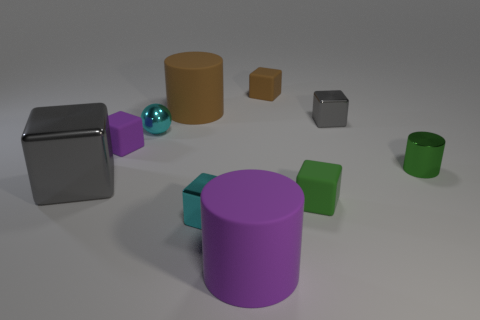Do the small metal cylinder and the large cylinder that is behind the tiny cyan metal block have the same color?
Give a very brief answer. No. Are there more purple matte objects than gray matte things?
Provide a short and direct response. Yes. Are there any other things of the same color as the small cylinder?
Provide a short and direct response. Yes. How many other things are there of the same size as the green metallic object?
Keep it short and to the point. 6. The cyan object that is behind the green thing that is in front of the green metallic cylinder that is in front of the large brown thing is made of what material?
Provide a succinct answer. Metal. Does the small purple thing have the same material as the cylinder on the right side of the small gray shiny thing?
Provide a succinct answer. No. Is the number of tiny purple cubes to the right of the small cyan metallic cube less than the number of small green objects that are to the left of the large gray object?
Provide a succinct answer. No. What number of other tiny brown cylinders are the same material as the brown cylinder?
Keep it short and to the point. 0. There is a green thing to the right of the small matte object on the right side of the tiny brown block; is there a green matte thing on the right side of it?
Your response must be concise. No. How many blocks are either gray metal things or big gray objects?
Your response must be concise. 2. 